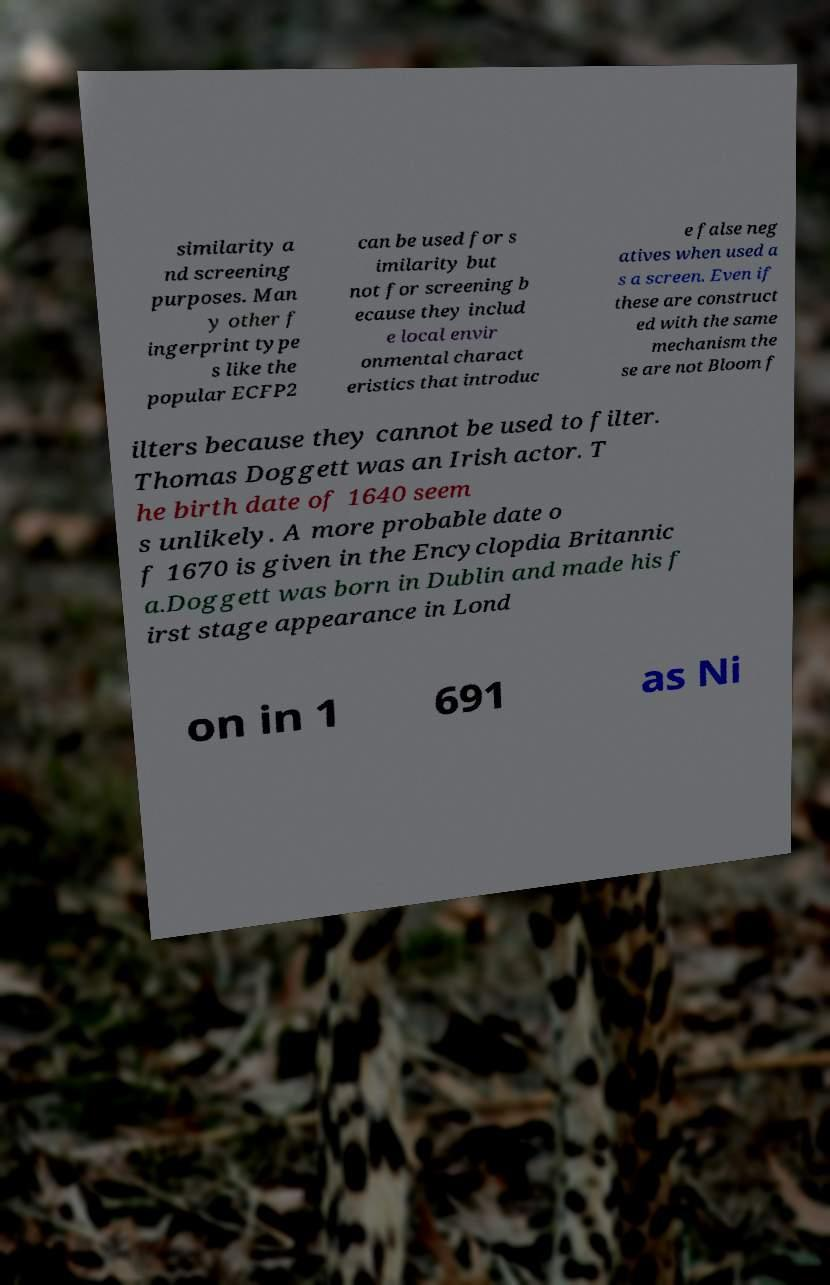There's text embedded in this image that I need extracted. Can you transcribe it verbatim? similarity a nd screening purposes. Man y other f ingerprint type s like the popular ECFP2 can be used for s imilarity but not for screening b ecause they includ e local envir onmental charact eristics that introduc e false neg atives when used a s a screen. Even if these are construct ed with the same mechanism the se are not Bloom f ilters because they cannot be used to filter. Thomas Doggett was an Irish actor. T he birth date of 1640 seem s unlikely. A more probable date o f 1670 is given in the Encyclopdia Britannic a.Doggett was born in Dublin and made his f irst stage appearance in Lond on in 1 691 as Ni 